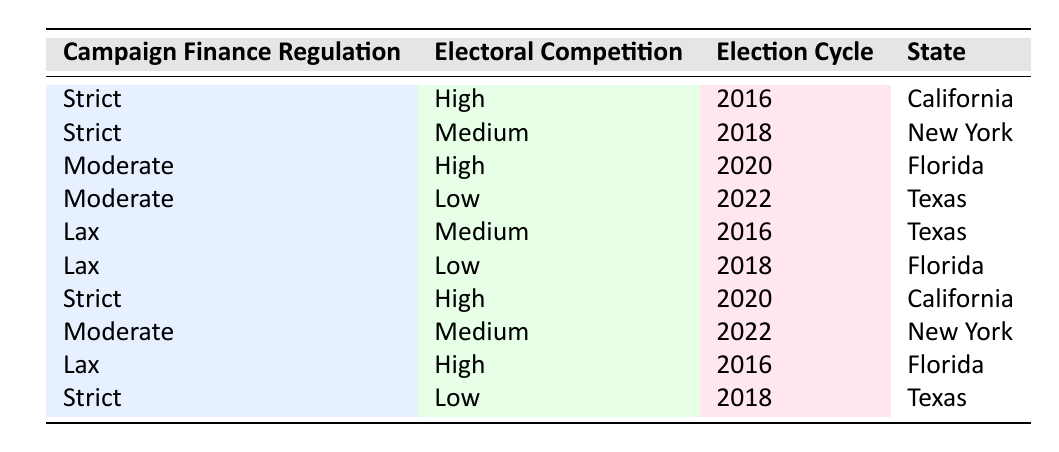What is the electoral competition level in California during the 2016 election cycle? From the table, in the row with "California" and the "2016" election cycle, the electoral competition is classified as "High".
Answer: High Which states had high electoral competition in 2020? Looking at the entries for the year 2020, "Florida" and "California" both show high electoral competition.
Answer: Florida, California Is there any instance of lax campaign finance regulation corresponding to high electoral competition? Checking the rows, there is no instance where "Lax" campaign finance regulation is associated with "High" electoral competition in the table.
Answer: No What is the average electoral competition level across all states for 2018? The entries for 2018 show "Medium" for New York and Texas, and "Low" for Texas and Florida. To find the average, we can assign values: High=3, Medium=2, Low=1. The sum is (2 + 1 + 1) / 3 = 1.33 (average rank value) leads to an average classification of between Low and Medium.
Answer: Between Low and Medium (average) Which type of campaign finance regulation corresponds to low electoral competition in Texas for the 2022 election cycle? In the row for Texas in the 2022 election cycle, the campaign finance regulation is "Moderate" while the electoral competition is "Low".
Answer: Moderate Did any strict campaign finance regulation lead to medium electoral competition in New York for the 2018 cycle? Checking the rows, New York in 2018 shows "Medium" electoral competition but with "Strict" campaign finance regulation, which is not mentioned. Therefore, this statement is false.
Answer: No How many states show a correlation between strict campaign finance regulations and high electoral competition across the given cycles? From the table, California is seen in 2016 and 2020 with "Strict" regulations and "High" competition. So, there are 2 instances (California in both years).
Answer: 2 What proportion of the total entries show moderate campaign finance regulations? There are 10 total entries in the table, and 3 of those (2020 Florida, 2022 Texas, and 2022 New York) show "Moderate" regulations. So the proportion is 3/10 = 0.3.
Answer: 0.3 In which election cycle did lax campaign finance regulations lead to low electoral competition? There is only one instance of "Lax" regulation associated with "Low" competition, which is in Florida during the 2018 cycle.
Answer: 2018 